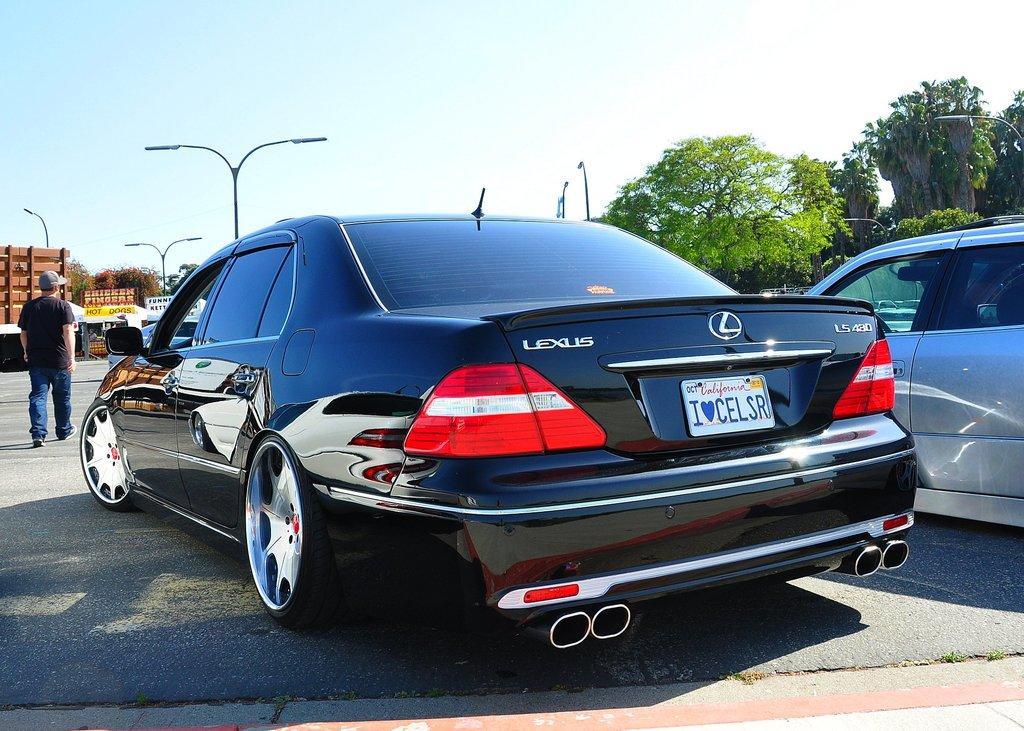How would you summarize this image in a sentence or two? On the left side of the image we can see a building, boards and a man is walking on the road and wearing a cap. In the background of the image we can see the trees, poles, lights, cars. At the bottom of the image we can see the road. At the top of the image we can see the sky. 